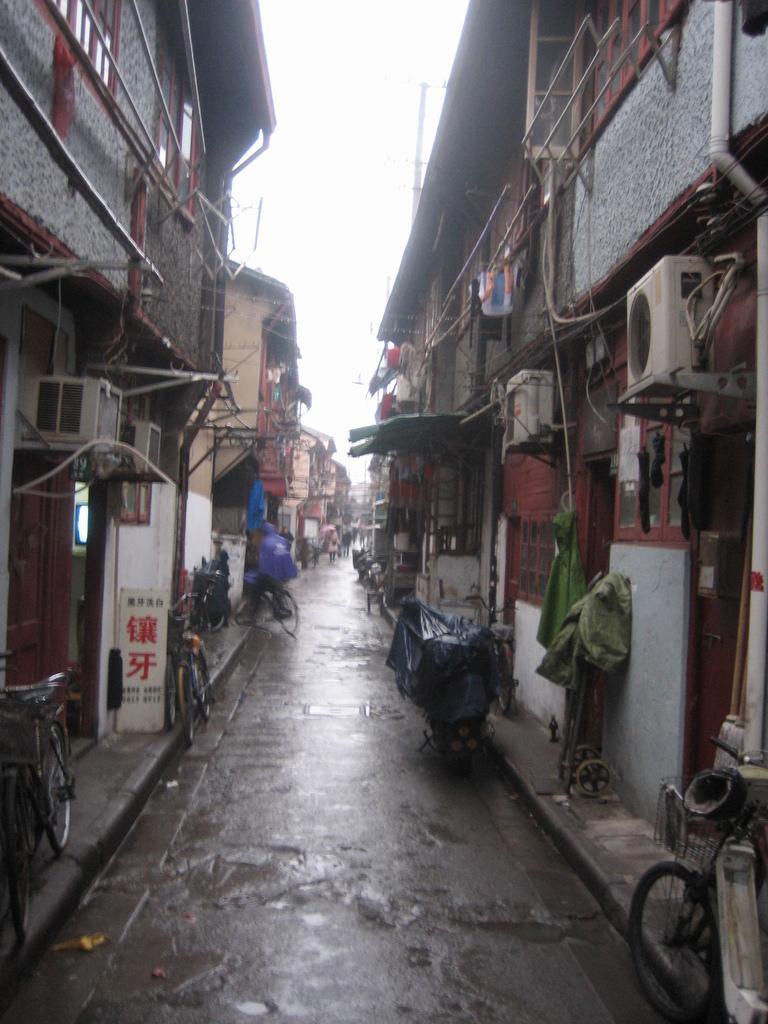Can you describe this image briefly? There are bicycles present on the road as we can see at the bottom of this image. There are buildings in the background and the sky is at the top of this image. 